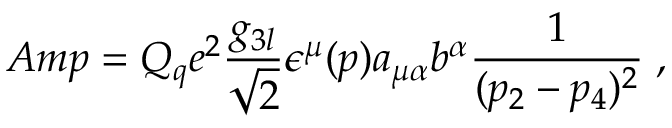Convert formula to latex. <formula><loc_0><loc_0><loc_500><loc_500>A m p = Q _ { q } e ^ { 2 } { \frac { g _ { 3 l } } { \sqrt { 2 } } } \epsilon ^ { \mu } ( p ) a _ { \mu \alpha } b ^ { \alpha } { \frac { 1 } { ( p _ { 2 } - p _ { 4 } ) ^ { 2 } } } \, ,</formula> 